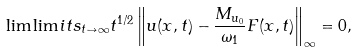<formula> <loc_0><loc_0><loc_500><loc_500>\lim \lim i t s _ { t \to \infty } t ^ { 1 / 2 } \left \| u ( x , t ) - \frac { M _ { u _ { 0 } } } { \omega _ { 1 } } F ( x , t ) \right \| _ { \infty } = 0 ,</formula> 